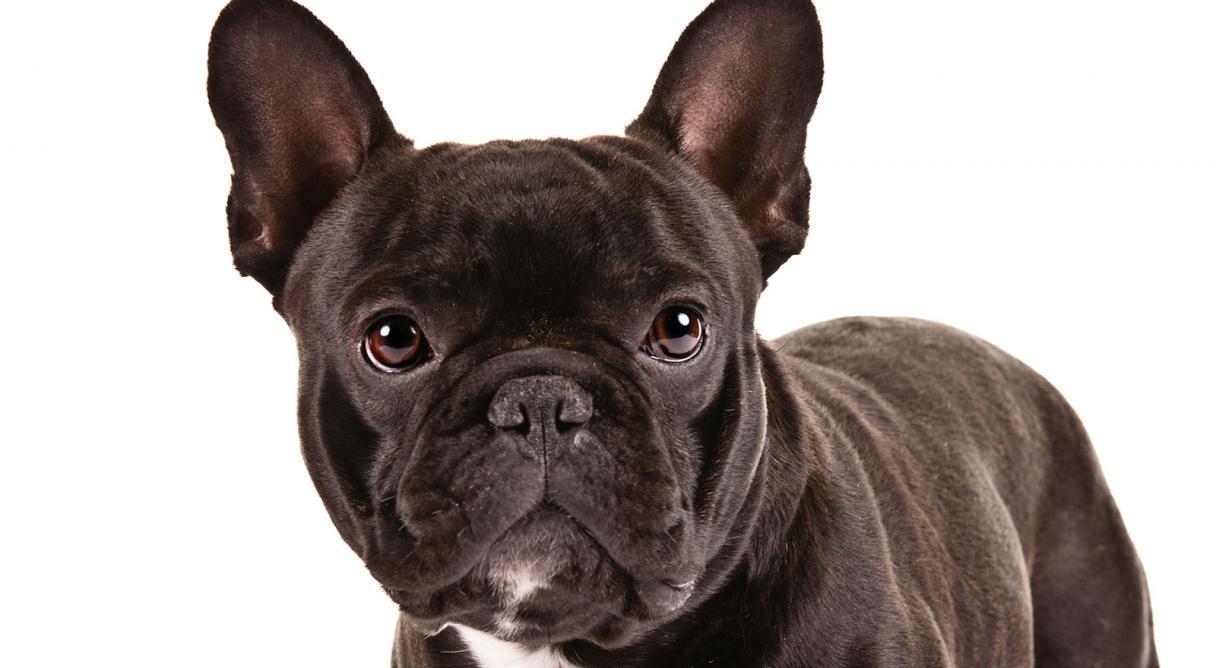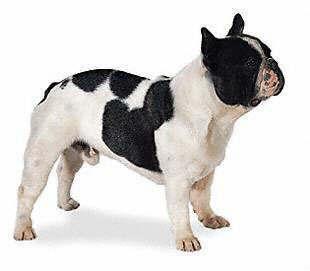The first image is the image on the left, the second image is the image on the right. For the images displayed, is the sentence "One  dog has an all-white body, excluding its head." factually correct? Answer yes or no. No. 